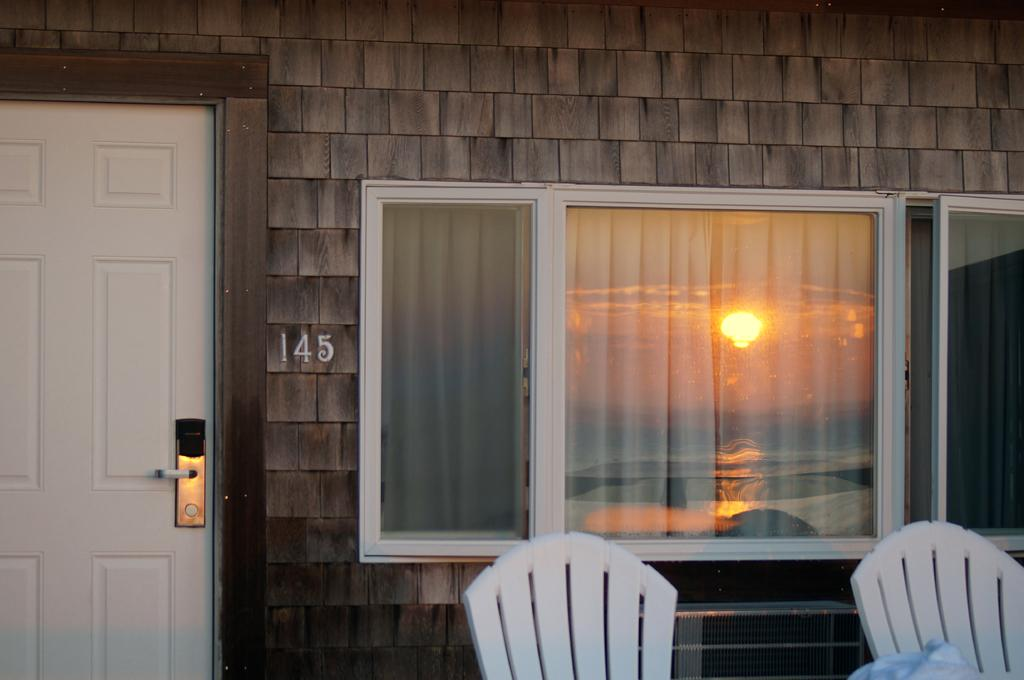What objects can be seen in the foreground of the image? There are chairs in the foreground of the image. Where are the chairs located? The chairs are on the floor. What can be seen in the background of the image? There are windows, a door, and a wall in the background of the image. What part of the natural environment is visible in the image? The sky is visible in the background of the image. What type of setting might the image depict? The image might have been taken in a room. What type of brass instrument is being played in the image? There is no brass instrument present in the image. What caption would best describe the image? The image does not have a caption, as it is a still photograph. Can you see any frogs in the image? There are no frogs present in the image. 